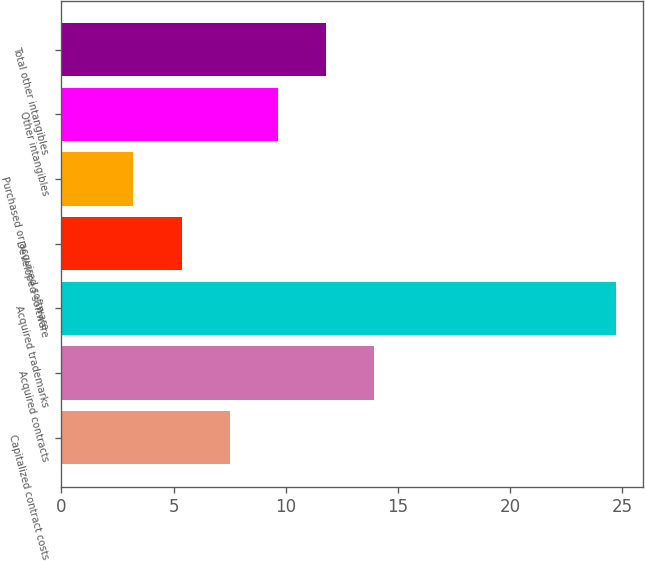Convert chart. <chart><loc_0><loc_0><loc_500><loc_500><bar_chart><fcel>Capitalized contract costs<fcel>Acquired contracts<fcel>Acquired trademarks<fcel>Developed software<fcel>Purchased or acquired software<fcel>Other intangibles<fcel>Total other intangibles<nl><fcel>7.5<fcel>13.95<fcel>24.7<fcel>5.35<fcel>3.2<fcel>9.65<fcel>11.8<nl></chart> 